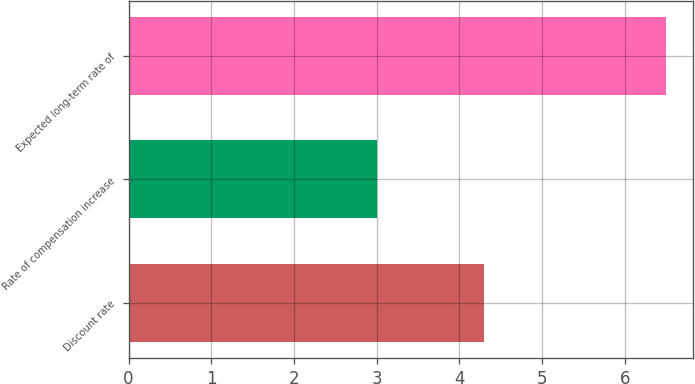Convert chart to OTSL. <chart><loc_0><loc_0><loc_500><loc_500><bar_chart><fcel>Discount rate<fcel>Rate of compensation increase<fcel>Expected long-term rate of<nl><fcel>4.3<fcel>3<fcel>6.5<nl></chart> 